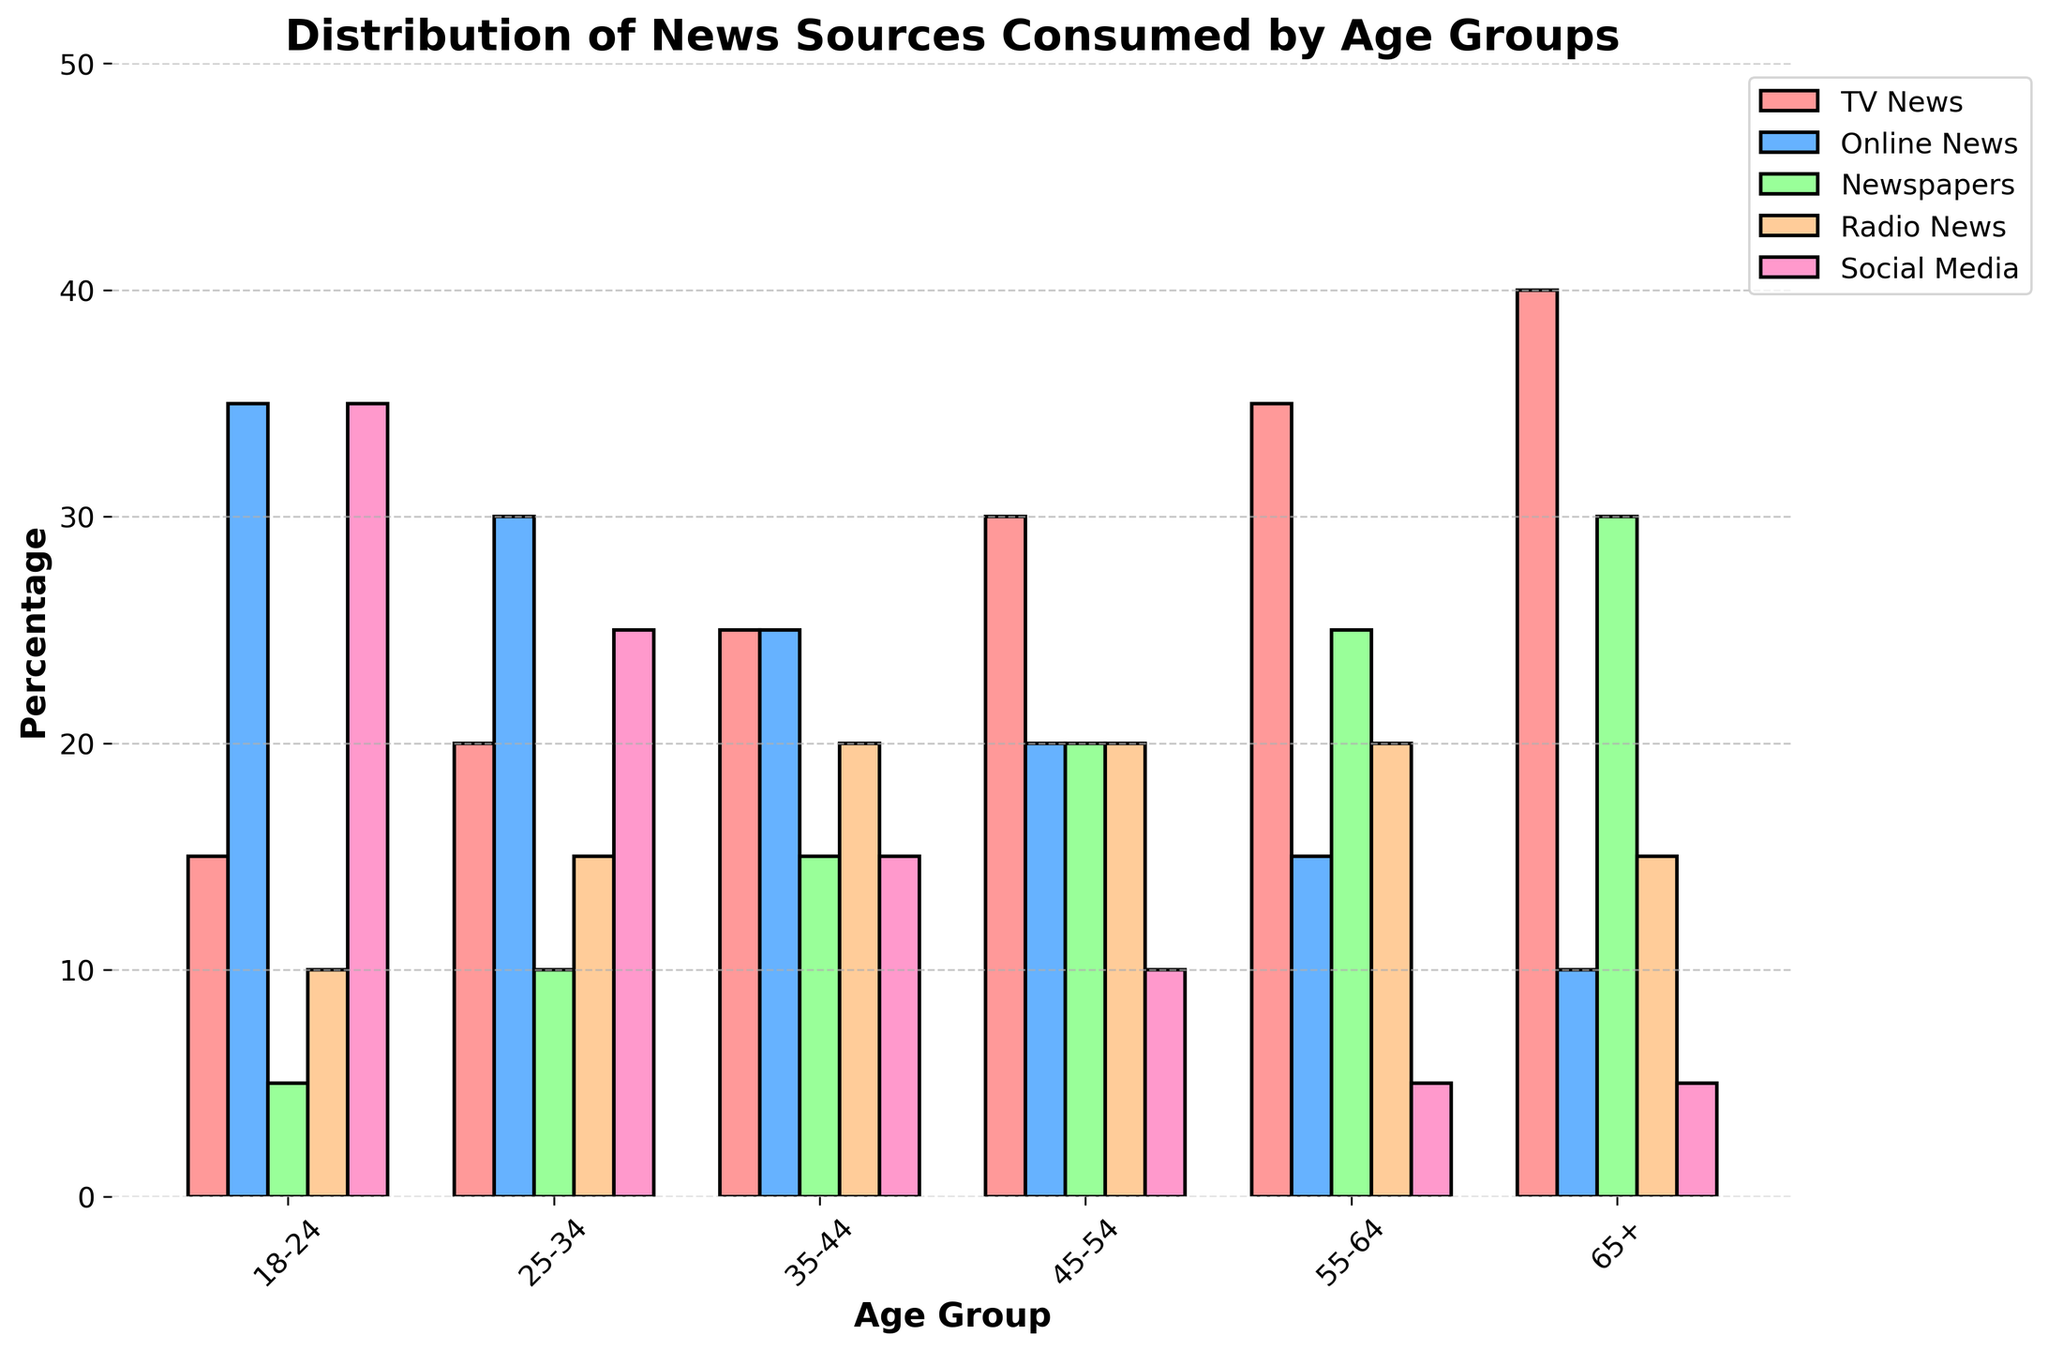What's the most popular news source for the 18-24 age group? Looking at the bars for the 18-24 age group, the tallest bar represents Social Media, indicating it is the most consumed news source among this age group.
Answer: Social Media Which age group consumes TV News the most? Comparing the bars representing TV News for each age group, the 65+ group has the tallest bar.
Answer: 65+ What is the combined percentage of Online News consumption for the age groups 25-34 and 35-44? Online News for 25-34 is 30% and for 35-44 it's 25%. Adding them together: 30 + 25 = 55.
Answer: 55 Is the consumption of Social Media higher for the 25-34 age group or the 45-54 age group? Comparing the Social Media bars for these two age groups, the bar is taller for the 25-34 group.
Answer: 25-34 What is the difference in Newspaper consumption between the 18-24 and 65+ age groups? Newspaper consumption for 18-24 is 5% and for 65+ it's 30%. The difference is 30 - 5 = 25.
Answer: 25 Which age group has the most balanced distribution of news sources? By looking at the bars' heights for each age group, the 35-44 group's bars are closer in height, indicating a more balanced distribution.
Answer: 35-44 How much more or less does the 55-64 age group consume Radio News compared to the 18-24 age group? The Radio News consumption for 55-64 is 20% and for 18-24 it's 10%. The difference is 20 - 10 = 10.
Answer: 10 more What's the least preferred news source for the 45-54 age group? Looking at the bars for the 45-54 age group, the shortest bar represents Social Media.
Answer: Social Media How does the trend in Newspaper consumption change as age increases? Observing the bars for Newspapers across age groups, the percentage generally increases as age increases.
Answer: Increases Compare the combined consumption of TV News and Online News for the 18-24 age group with that for the 65+ age group. For 18-24, TV News is 15% and Online News is 35%. Their sum is 15 + 35 = 50%. For 65+, TV News is 40% and Online News is 10%. Their sum is 40 + 10 = 50%. Both age groups have the same combined percentage.
Answer: Equal 